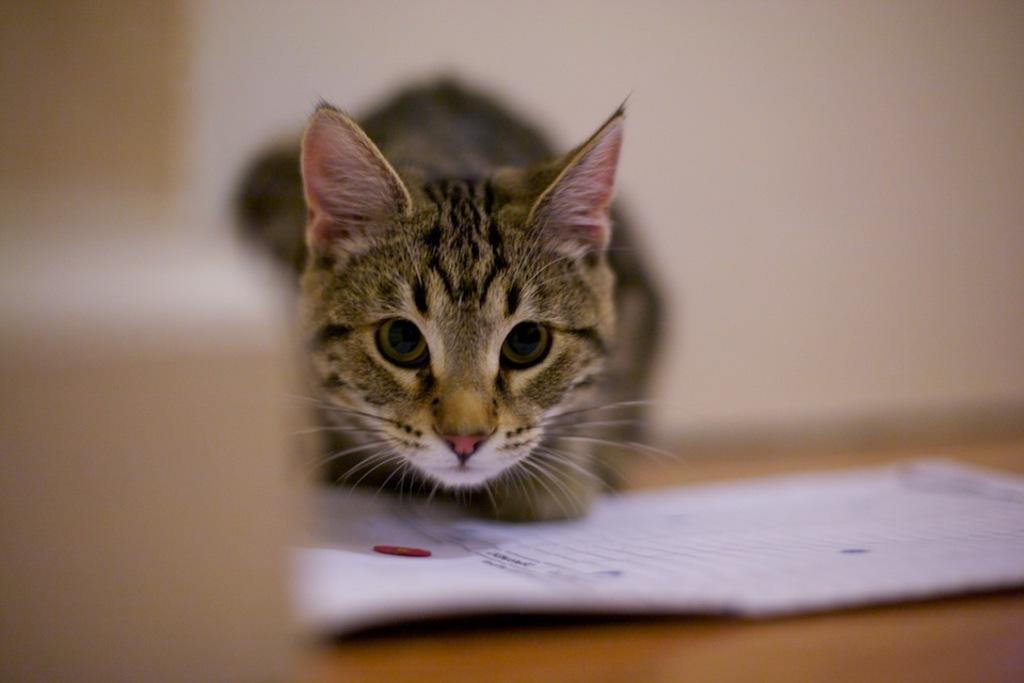What animal can be seen in the image? There is a cat in the image. What is in front of the cat? There is a paper in front of the cat. Can you describe the background of the image? The background of the image is blurred. What type of zinc is the cat using to play music in the image? There is no zinc or music present in the image; it features a cat with a paper in front of it. What loss is the cat experiencing in the image? There is no indication of loss in the image; it simply shows a cat with a paper in front of it. 